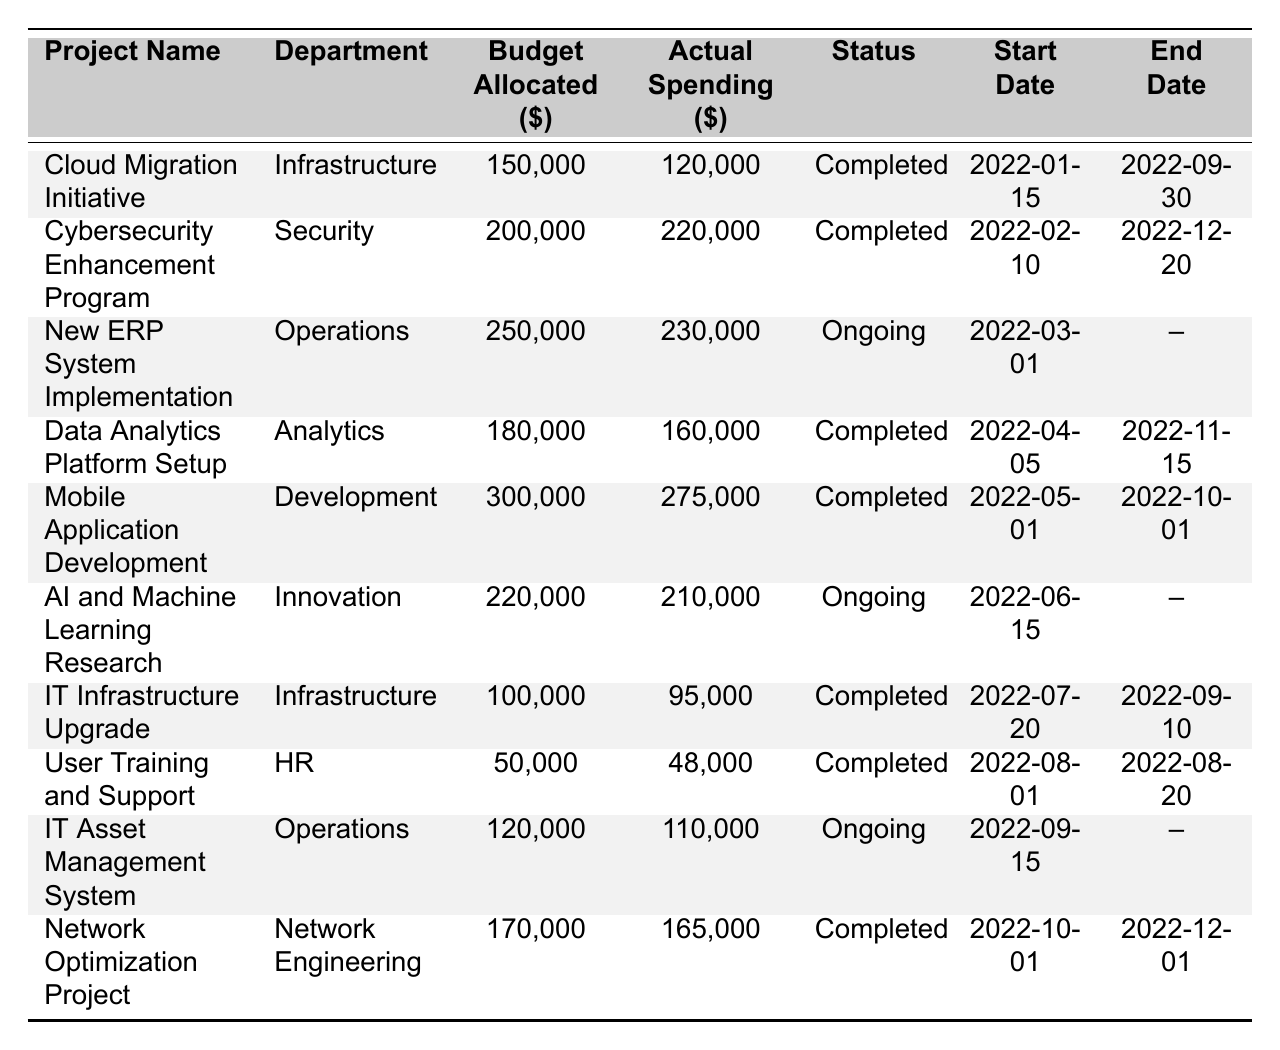What is the budget allocated for the "AI and Machine Learning Research" project? The table indicates that the budget allocated for the "AI and Machine Learning Research" project is listed under the "Budget Allocated ($)" column corresponding to that project. The value there is 220,000.
Answer: 220000 Which project has the highest actual spending? To find the project with the highest actual spending, I will look at the "Actual Spending ($)" column and identify the maximum value. The project "Cybersecurity Enhancement Program" has the highest actual spending of 220,000.
Answer: Cybersecurity Enhancement Program What is the total budget allocated for all completed projects? I will sum the budget allocated for all projects marked as "Completed." The projects are: Cloud Migration Initiative (150,000), Cybersecurity Enhancement Program (200,000), Data Analytics Platform Setup (180,000), Mobile Application Development (300,000), IT Infrastructure Upgrade (100,000), User Training and Support (50,000), and Network Optimization Project (170,000). The total is (150,000 + 200,000 + 180,000 + 300,000 + 100,000 + 50,000 + 170,000) = 1,150,000.
Answer: 1150000 How much less was spent on the "IT Infrastructure Upgrade" project compared to its allocated budget? I will find the difference between the budget allocated and the actual spending for the "IT Infrastructure Upgrade" project. The budget allocated is 100,000 and the actual spending is 95,000. The difference is (100,000 - 95,000) = 5,000.
Answer: 5000 Is there any project that spent more than its allocated budget? I will check the "Actual Spending ($)" values and compare them with the respective "Budget Allocated ($)" values. The "Cybersecurity Enhancement Program" spent 220,000, which is greater than the allocated budget of 200,000, indicating that it did indeed exceed its budget.
Answer: Yes What is the average budget allocated across all projects? I will sum the budget allocated values for all projects and then divide by the number of projects. The total budget allocated is (150,000 + 200,000 + 250,000 + 180,000 + 300,000 + 220,000 + 100,000 + 50,000 + 120,000 + 170,000) = 1,740,000. There are 10 projects, so the average is 1,740,000 / 10 = 174,000.
Answer: 174000 Which department has the most ongoing projects? I will review the "Project Status" column and count the number of projects listed as "Ongoing" for each department. The departments with ongoing projects are Operations (2) and Innovation (1). Therefore, the department with the most ongoing projects is Operations with 2 projects.
Answer: Operations What is the end date of the "New ERP System Implementation" project? I will look at the "New ERP System Implementation" project and check the "End Date" column for that project. It shows a "null" value, indicating that there is no end date listed because the project is ongoing.
Answer: No end date (ongoing) What percentage of the budget was actually spent on the "Mobile Application Development" project? First, I will calculate the percentage spent using the formula: (Actual Spending / Budget Allocated) * 100. The actual spending is 275,000 and the budget allocated is 300,000, so the percentage spent is (275,000 / 300,000) * 100 = 91.67%.
Answer: 91.67% 